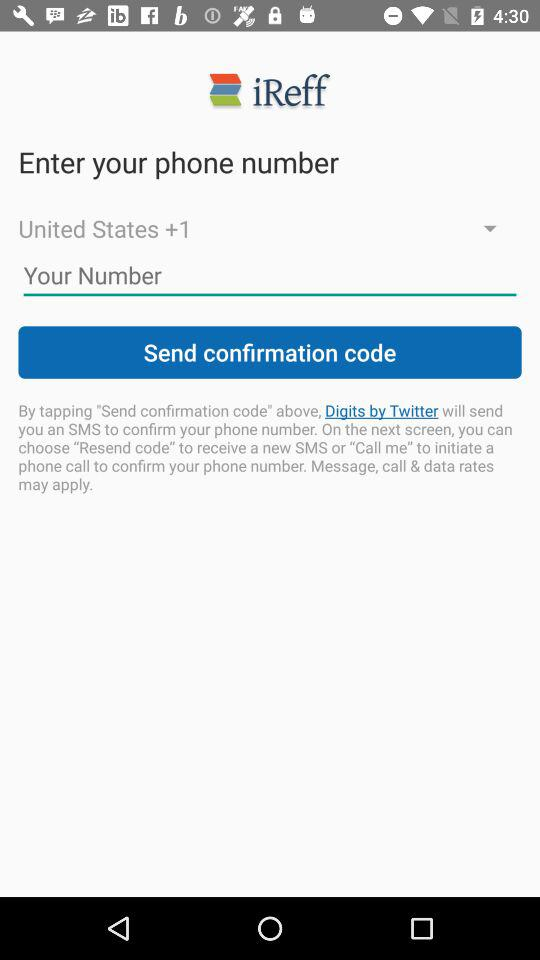Which other country codes are available in the drop-down menu?
When the provided information is insufficient, respond with <no answer>. <no answer> 